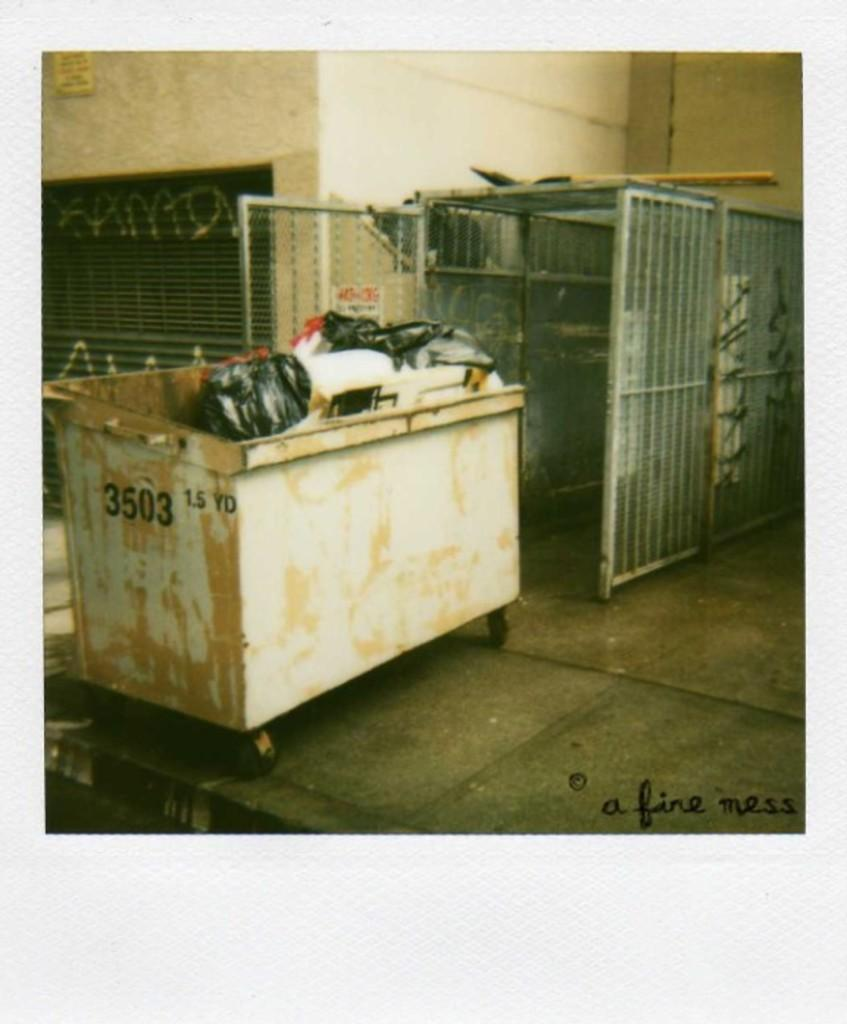<image>
Render a clear and concise summary of the photo. a beige dumpster peeling white paint with the numbers 3503 on it 